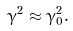Convert formula to latex. <formula><loc_0><loc_0><loc_500><loc_500>\gamma ^ { 2 } \approx \gamma _ { 0 } ^ { 2 } .</formula> 